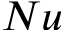<formula> <loc_0><loc_0><loc_500><loc_500>N u</formula> 